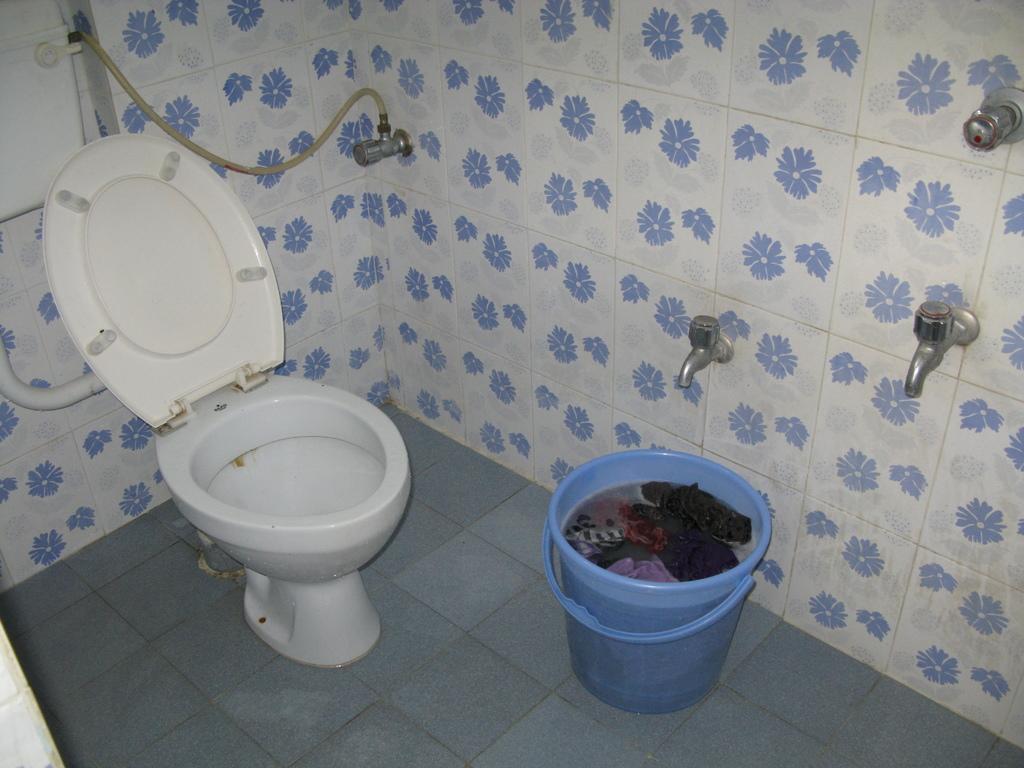In one or two sentences, can you explain what this image depicts? In this image we can see a toilet seat and a bucket, in the bucket we can see some water and clothes, on the wall there are some taps. 